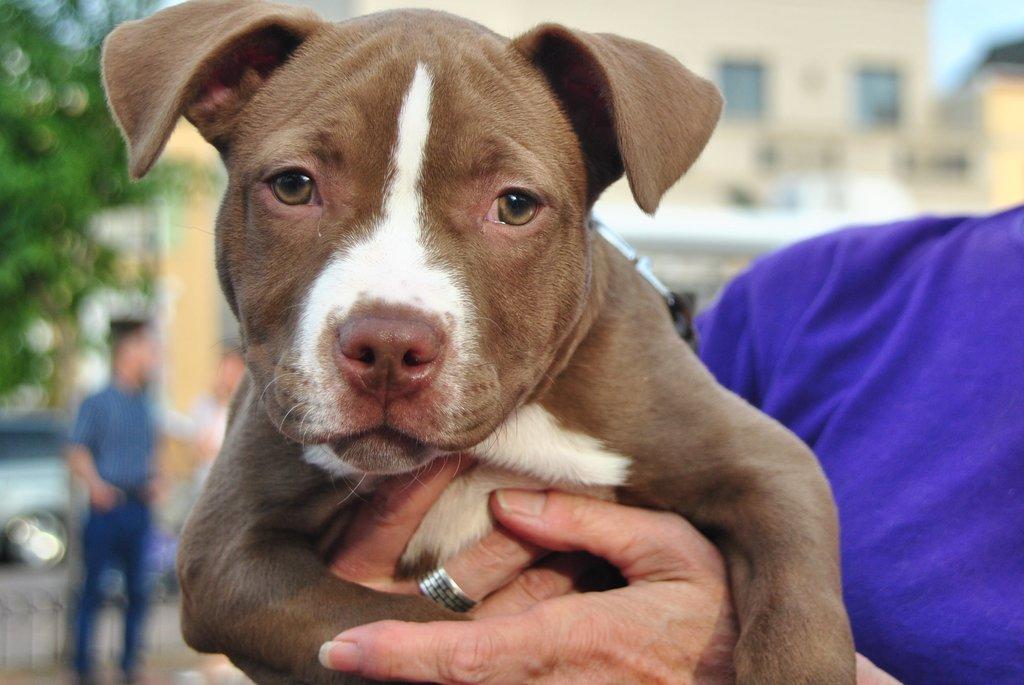Could you give a brief overview of what you see in this image? In this image, on the right there is a person holding a dog. In the background there are people, vehicles, trees, buildings. 